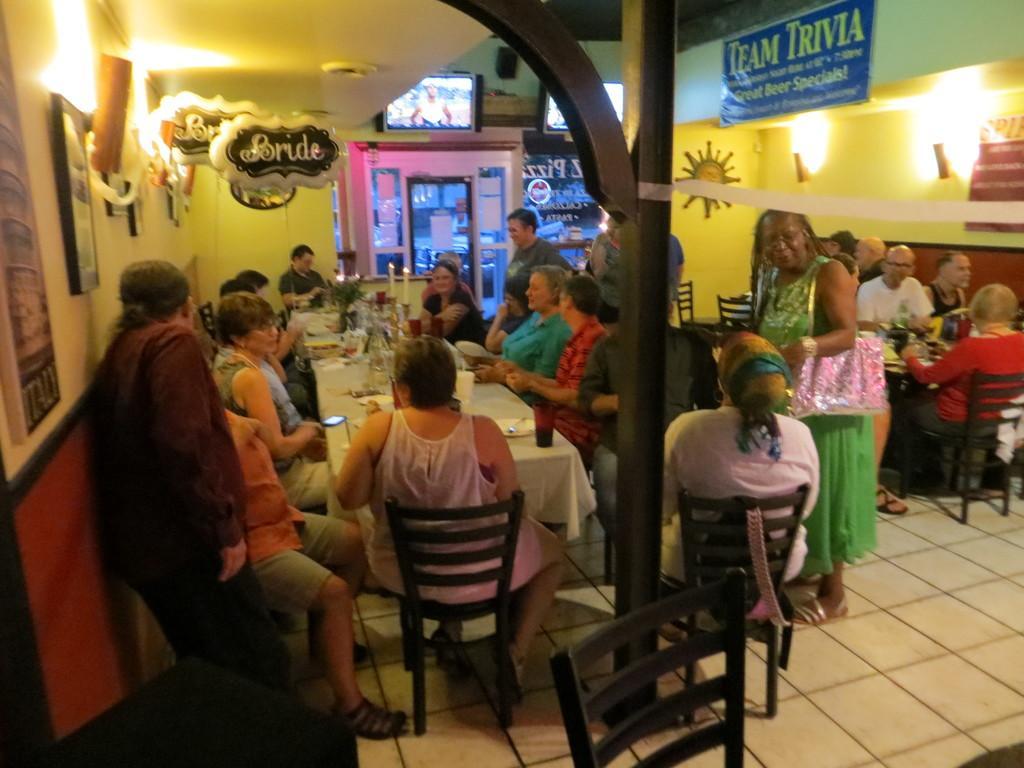In one or two sentences, can you explain what this image depicts? In this picture i could see many persons sitting around dining table and having the food in the background i could see balloons hanging. 